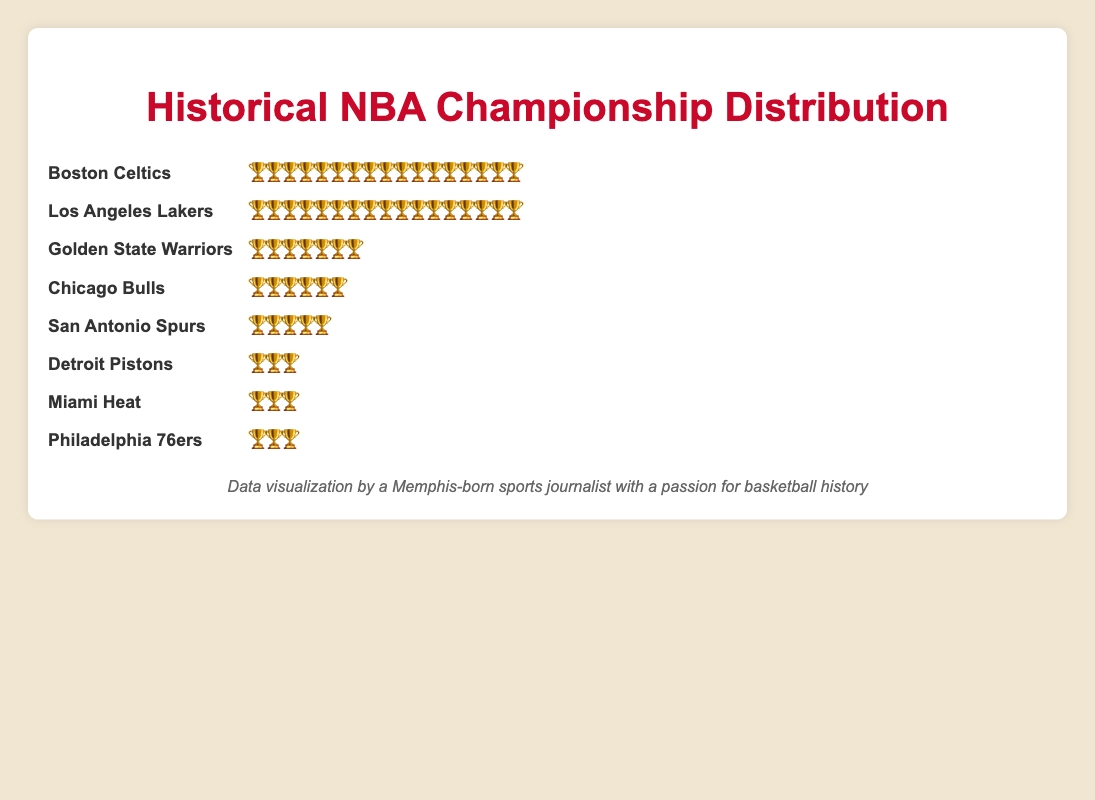Which two teams have the highest number of championships? The Isotype Plot shows the number of trophies next to each team name. The Boston Celtics and the Los Angeles Lakers each have 17 trophies.
Answer: Boston Celtics and Los Angeles Lakers Which team has more championships, the Chicago Bulls or the San Antonio Spurs? The Isotype Plot indicates that the Chicago Bulls have 6 trophies, while the San Antonio Spurs have 5 trophies.
Answer: Chicago Bulls How many teams have won exactly 3 championships? The Isotype Plot shows that the Detroit Pistons, Miami Heat, and Philadelphia 76ers each have 3 trophies, making it 3 teams in total.
Answer: 3 teams What is the total number of championships won by the Boston Celtics and the Los Angeles Lakers combined? The plot shows 17 trophies for each of these teams. Adding them together, 17 + 17 equals 34 championships.
Answer: 34 Which team has won the same number of championships as the Golden State Warriors? The Isotype Plot shows that the Golden State Warriors have 7 trophies, and no other team has exactly 7 trophies displayed.
Answer: None How many more championships do the Golden State Warriors have compared to the Detroit Pistons? The Warriors have 7 trophies and the Pistons have 3 trophies according to the plot. 7 - 3 equals 4 more championships.
Answer: 4 more championships Rank these teams by their number of championships: Chicago Bulls, Miami Heat, and San Antonio Spurs. According to the plot, the Chicago Bulls have 6 trophies, the San Antonio Spurs have 5 trophies, and the Miami Heat have 3 trophies. Therefore, the ranking is Chicago Bulls > San Antonio Spurs > Miami Heat.
Answer: Chicago Bulls > San Antonio Spurs > Miami Heat Which team displayed has the fewest championships and how many do they have? The Isotype Plot shows the fewest number of trophies next to the Detroit Pistons, Miami Heat, and Philadelphia 76ers, each with 3 trophies.
Answer: Detroit Pistons, Miami Heat, Philadelphia 76ers, each with 3 championships If you add the number of trophies from the Miami Heat and the Philadelphia 76ers, how many is that? The plot shows 3 trophies for each of these teams. Adding them, 3 + 3 equals 6 championships.
Answer: 6 championships 